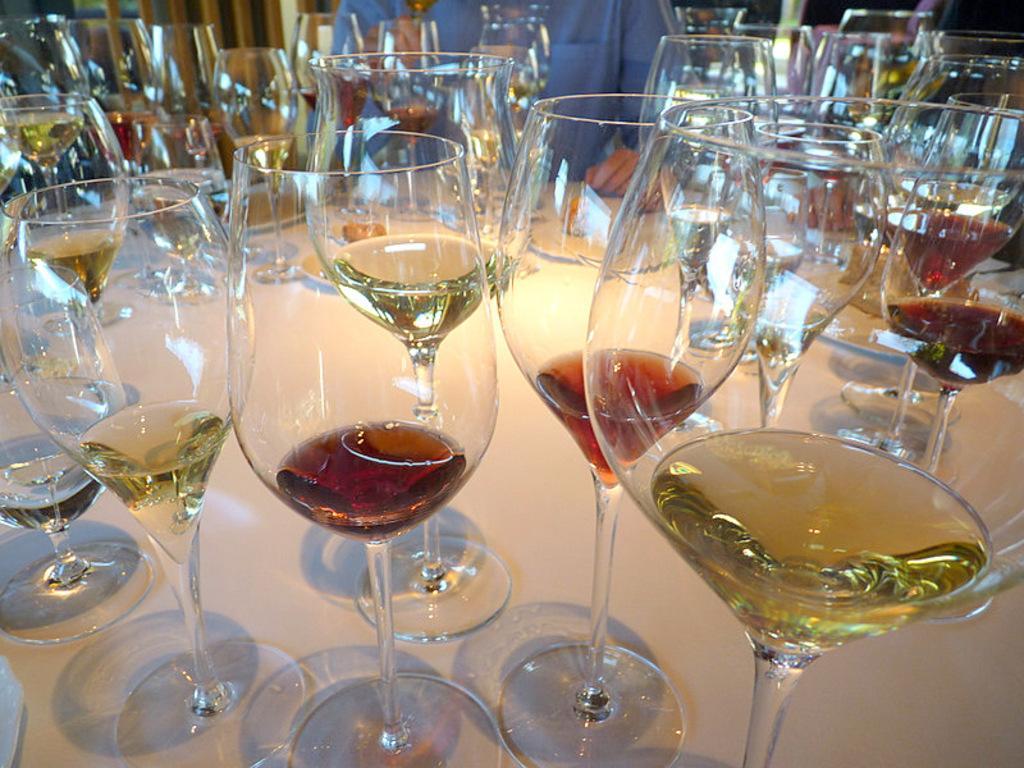Can you describe this image briefly? In this image I can see few glasses. In the background I can see a person. I can see some drink in the glasses. 